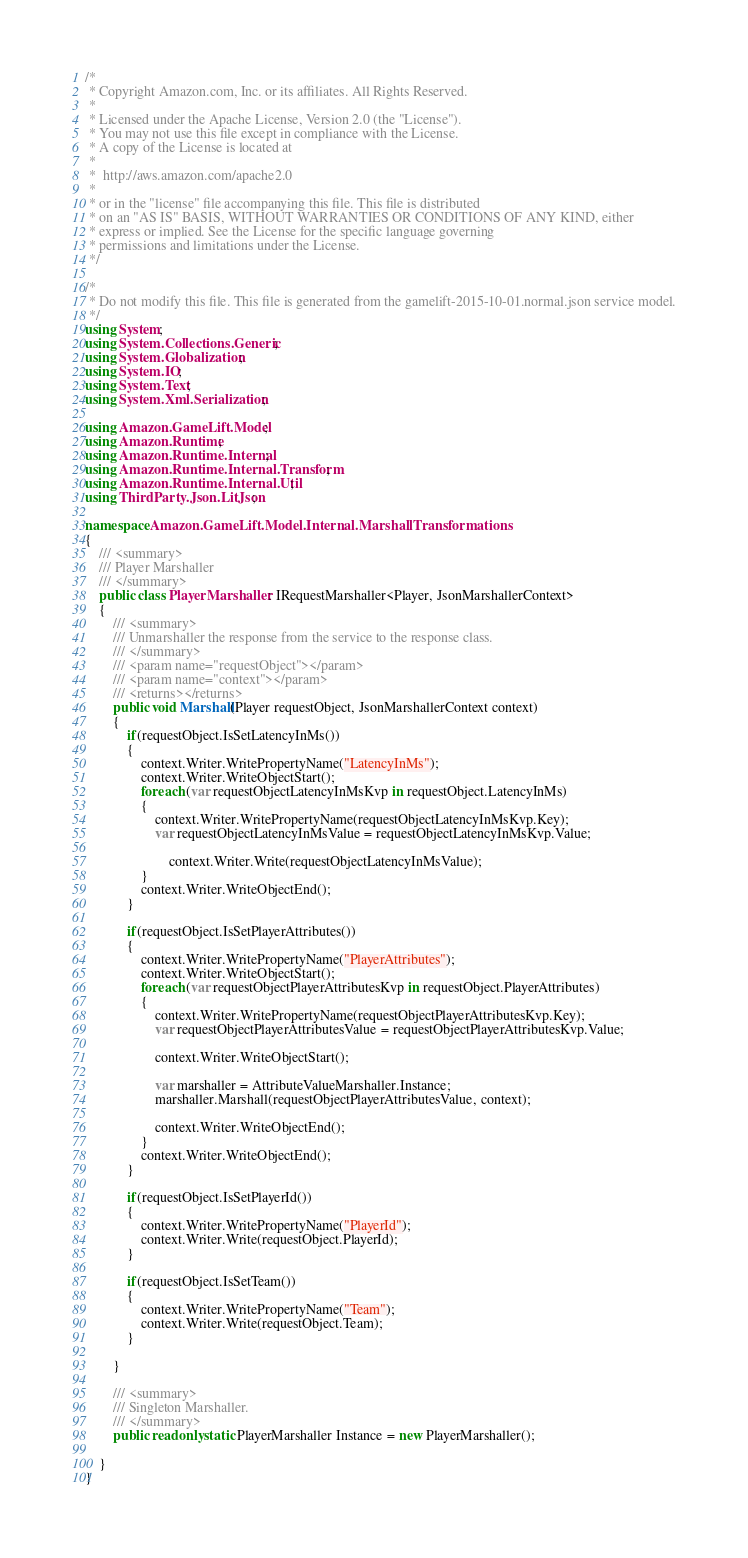<code> <loc_0><loc_0><loc_500><loc_500><_C#_>/*
 * Copyright Amazon.com, Inc. or its affiliates. All Rights Reserved.
 * 
 * Licensed under the Apache License, Version 2.0 (the "License").
 * You may not use this file except in compliance with the License.
 * A copy of the License is located at
 * 
 *  http://aws.amazon.com/apache2.0
 * 
 * or in the "license" file accompanying this file. This file is distributed
 * on an "AS IS" BASIS, WITHOUT WARRANTIES OR CONDITIONS OF ANY KIND, either
 * express or implied. See the License for the specific language governing
 * permissions and limitations under the License.
 */

/*
 * Do not modify this file. This file is generated from the gamelift-2015-10-01.normal.json service model.
 */
using System;
using System.Collections.Generic;
using System.Globalization;
using System.IO;
using System.Text;
using System.Xml.Serialization;

using Amazon.GameLift.Model;
using Amazon.Runtime;
using Amazon.Runtime.Internal;
using Amazon.Runtime.Internal.Transform;
using Amazon.Runtime.Internal.Util;
using ThirdParty.Json.LitJson;

namespace Amazon.GameLift.Model.Internal.MarshallTransformations
{
    /// <summary>
    /// Player Marshaller
    /// </summary>       
    public class PlayerMarshaller : IRequestMarshaller<Player, JsonMarshallerContext> 
    {
        /// <summary>
        /// Unmarshaller the response from the service to the response class.
        /// </summary>  
        /// <param name="requestObject"></param>
        /// <param name="context"></param>
        /// <returns></returns>
        public void Marshall(Player requestObject, JsonMarshallerContext context)
        {
            if(requestObject.IsSetLatencyInMs())
            {
                context.Writer.WritePropertyName("LatencyInMs");
                context.Writer.WriteObjectStart();
                foreach (var requestObjectLatencyInMsKvp in requestObject.LatencyInMs)
                {
                    context.Writer.WritePropertyName(requestObjectLatencyInMsKvp.Key);
                    var requestObjectLatencyInMsValue = requestObjectLatencyInMsKvp.Value;

                        context.Writer.Write(requestObjectLatencyInMsValue);
                }
                context.Writer.WriteObjectEnd();
            }

            if(requestObject.IsSetPlayerAttributes())
            {
                context.Writer.WritePropertyName("PlayerAttributes");
                context.Writer.WriteObjectStart();
                foreach (var requestObjectPlayerAttributesKvp in requestObject.PlayerAttributes)
                {
                    context.Writer.WritePropertyName(requestObjectPlayerAttributesKvp.Key);
                    var requestObjectPlayerAttributesValue = requestObjectPlayerAttributesKvp.Value;

                    context.Writer.WriteObjectStart();

                    var marshaller = AttributeValueMarshaller.Instance;
                    marshaller.Marshall(requestObjectPlayerAttributesValue, context);

                    context.Writer.WriteObjectEnd();
                }
                context.Writer.WriteObjectEnd();
            }

            if(requestObject.IsSetPlayerId())
            {
                context.Writer.WritePropertyName("PlayerId");
                context.Writer.Write(requestObject.PlayerId);
            }

            if(requestObject.IsSetTeam())
            {
                context.Writer.WritePropertyName("Team");
                context.Writer.Write(requestObject.Team);
            }

        }

        /// <summary>
        /// Singleton Marshaller.
        /// </summary>  
        public readonly static PlayerMarshaller Instance = new PlayerMarshaller();

    }
}</code> 